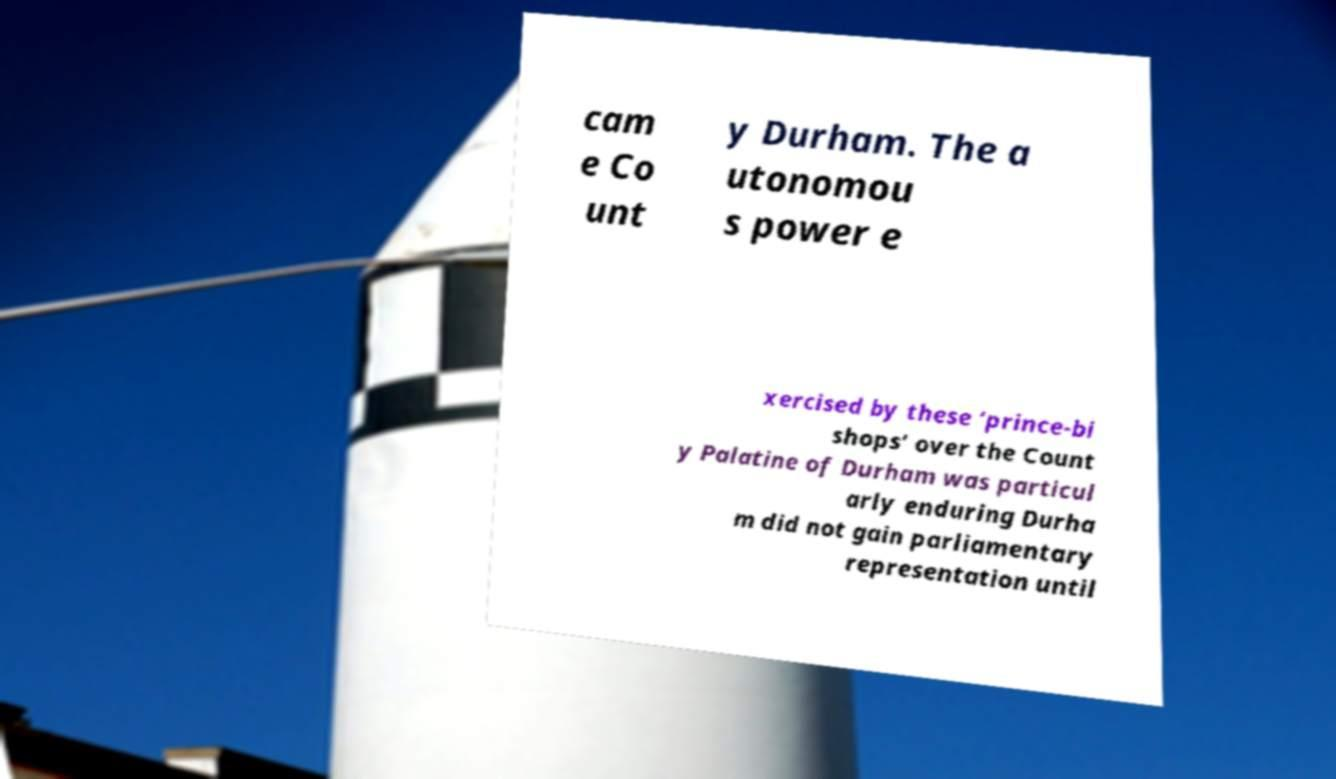Can you accurately transcribe the text from the provided image for me? cam e Co unt y Durham. The a utonomou s power e xercised by these ‘prince-bi shops’ over the Count y Palatine of Durham was particul arly enduring Durha m did not gain parliamentary representation until 